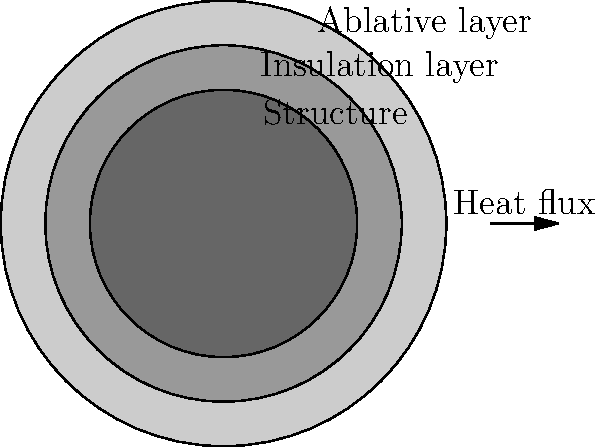In the cross-sectional diagram of a hypersonic vehicle's heat shield, what is the primary function of the outermost layer, and how does it contribute to the overall thermal protection system? To understand the function of the outermost layer in a hypersonic vehicle's heat shield, let's break down the thermal protection system:

1. The diagram shows three distinct layers of the heat shield, moving from outside to inside:
   a) Outermost layer (lightest gray)
   b) Middle layer (medium gray)
   c) Inner layer (darkest gray)

2. The outermost layer is labeled as the "Ablative layer." This is the key to answering the question.

3. Ablative materials are designed to slowly burn away in extreme heat conditions. This process is called ablation.

4. The function of the ablative layer:
   a) It absorbs enormous amounts of heat during the ablation process.
   b) As it burns away, it carries heat away from the vehicle.
   c) The ablation process creates a boundary layer of cooler gas around the vehicle, further insulating it from heat.

5. The middle "Insulation layer" provides additional thermal protection by slowing heat transfer to the inner structure.

6. The innermost "Structure" layer is the vehicle's main body, which must be protected from extreme temperatures.

7. The arrow labeled "Heat flux" indicates the direction of incoming heat during hypersonic flight.

In summary, the primary function of the outermost ablative layer is to absorb and dissipate heat through controlled degradation, protecting the vehicle from the extreme temperatures experienced during hypersonic flight.
Answer: Heat absorption and dissipation through controlled degradation (ablation) 